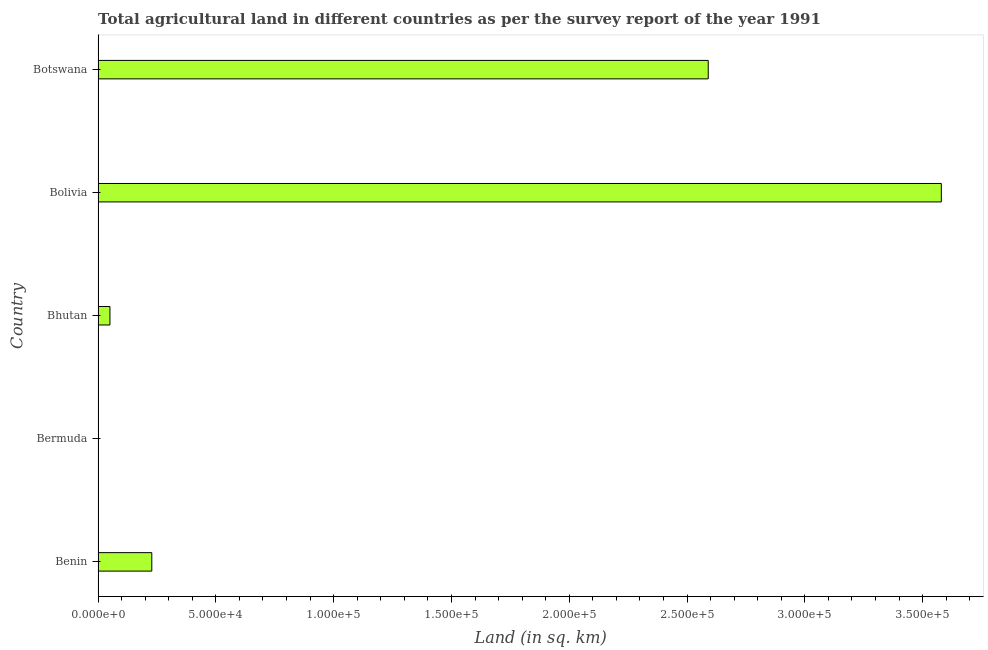Does the graph contain any zero values?
Ensure brevity in your answer.  No. Does the graph contain grids?
Offer a very short reply. No. What is the title of the graph?
Your answer should be very brief. Total agricultural land in different countries as per the survey report of the year 1991. What is the label or title of the X-axis?
Ensure brevity in your answer.  Land (in sq. km). What is the label or title of the Y-axis?
Offer a terse response. Country. Across all countries, what is the maximum agricultural land?
Give a very brief answer. 3.58e+05. In which country was the agricultural land minimum?
Offer a very short reply. Bermuda. What is the sum of the agricultural land?
Your answer should be very brief. 6.45e+05. What is the difference between the agricultural land in Benin and Bermuda?
Give a very brief answer. 2.28e+04. What is the average agricultural land per country?
Make the answer very short. 1.29e+05. What is the median agricultural land?
Provide a short and direct response. 2.28e+04. What is the ratio of the agricultural land in Benin to that in Bolivia?
Provide a short and direct response. 0.06. What is the difference between the highest and the second highest agricultural land?
Provide a short and direct response. 9.90e+04. What is the difference between the highest and the lowest agricultural land?
Offer a very short reply. 3.58e+05. In how many countries, is the agricultural land greater than the average agricultural land taken over all countries?
Ensure brevity in your answer.  2. Are all the bars in the graph horizontal?
Your response must be concise. Yes. What is the Land (in sq. km) of Benin?
Give a very brief answer. 2.28e+04. What is the Land (in sq. km) of Bermuda?
Provide a succinct answer. 3. What is the Land (in sq. km) of Bhutan?
Ensure brevity in your answer.  5040. What is the Land (in sq. km) of Bolivia?
Your answer should be compact. 3.58e+05. What is the Land (in sq. km) of Botswana?
Your answer should be very brief. 2.59e+05. What is the difference between the Land (in sq. km) in Benin and Bermuda?
Your answer should be compact. 2.28e+04. What is the difference between the Land (in sq. km) in Benin and Bhutan?
Ensure brevity in your answer.  1.78e+04. What is the difference between the Land (in sq. km) in Benin and Bolivia?
Ensure brevity in your answer.  -3.35e+05. What is the difference between the Land (in sq. km) in Benin and Botswana?
Your response must be concise. -2.36e+05. What is the difference between the Land (in sq. km) in Bermuda and Bhutan?
Offer a very short reply. -5037. What is the difference between the Land (in sq. km) in Bermuda and Bolivia?
Your answer should be compact. -3.58e+05. What is the difference between the Land (in sq. km) in Bermuda and Botswana?
Your answer should be compact. -2.59e+05. What is the difference between the Land (in sq. km) in Bhutan and Bolivia?
Give a very brief answer. -3.53e+05. What is the difference between the Land (in sq. km) in Bhutan and Botswana?
Make the answer very short. -2.54e+05. What is the difference between the Land (in sq. km) in Bolivia and Botswana?
Offer a terse response. 9.90e+04. What is the ratio of the Land (in sq. km) in Benin to that in Bermuda?
Your answer should be very brief. 7600. What is the ratio of the Land (in sq. km) in Benin to that in Bhutan?
Ensure brevity in your answer.  4.52. What is the ratio of the Land (in sq. km) in Benin to that in Bolivia?
Provide a succinct answer. 0.06. What is the ratio of the Land (in sq. km) in Benin to that in Botswana?
Your answer should be compact. 0.09. What is the ratio of the Land (in sq. km) in Bermuda to that in Bolivia?
Keep it short and to the point. 0. What is the ratio of the Land (in sq. km) in Bermuda to that in Botswana?
Give a very brief answer. 0. What is the ratio of the Land (in sq. km) in Bhutan to that in Bolivia?
Your response must be concise. 0.01. What is the ratio of the Land (in sq. km) in Bhutan to that in Botswana?
Offer a terse response. 0.02. What is the ratio of the Land (in sq. km) in Bolivia to that in Botswana?
Provide a short and direct response. 1.38. 